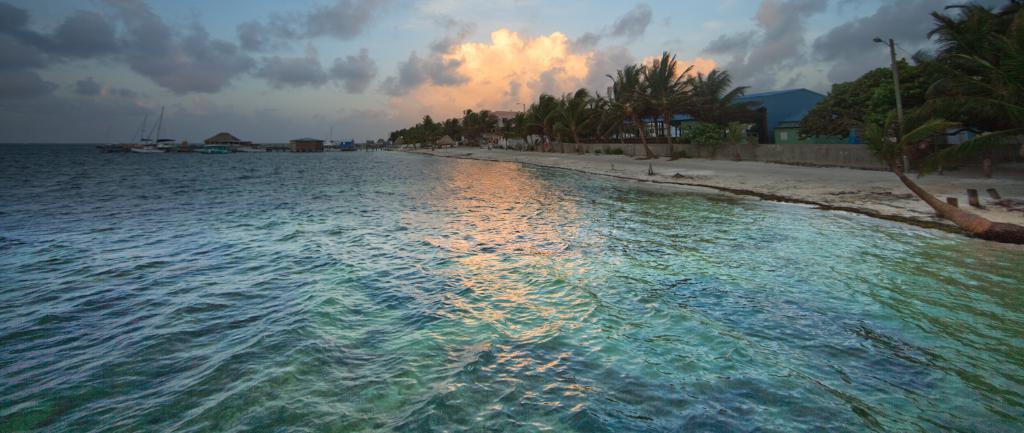Please provide a concise description of this image. In this picture I can see the ocean. On the right I can see the trees, shed, fencing and plants. In the background I can see the boats on the water. At the top I can see the sky and clouds. 